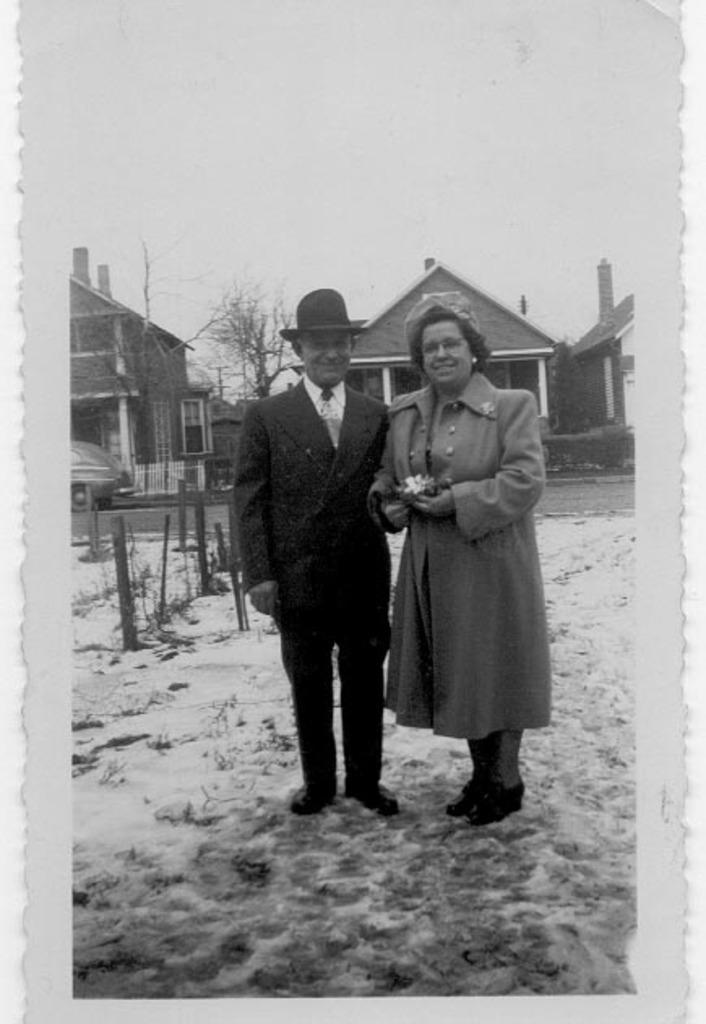What is the color scheme of the image? The image is black and white. Who or what can be seen in the image? There is a couple in the image. What is the couple standing on? The couple is standing on snow. What can be seen in the background of the image? There are poles, a road, vehicles, a treehouse, and the sky visible in the background of the image. What company does the cow in the image represent? There is no cow present in the image. How does the act of standing on snow affect the couple's balance in the image? The image does not show the couple's balance or any actions they might be taking, so it is not possible to determine how standing on snow affects their balance. 